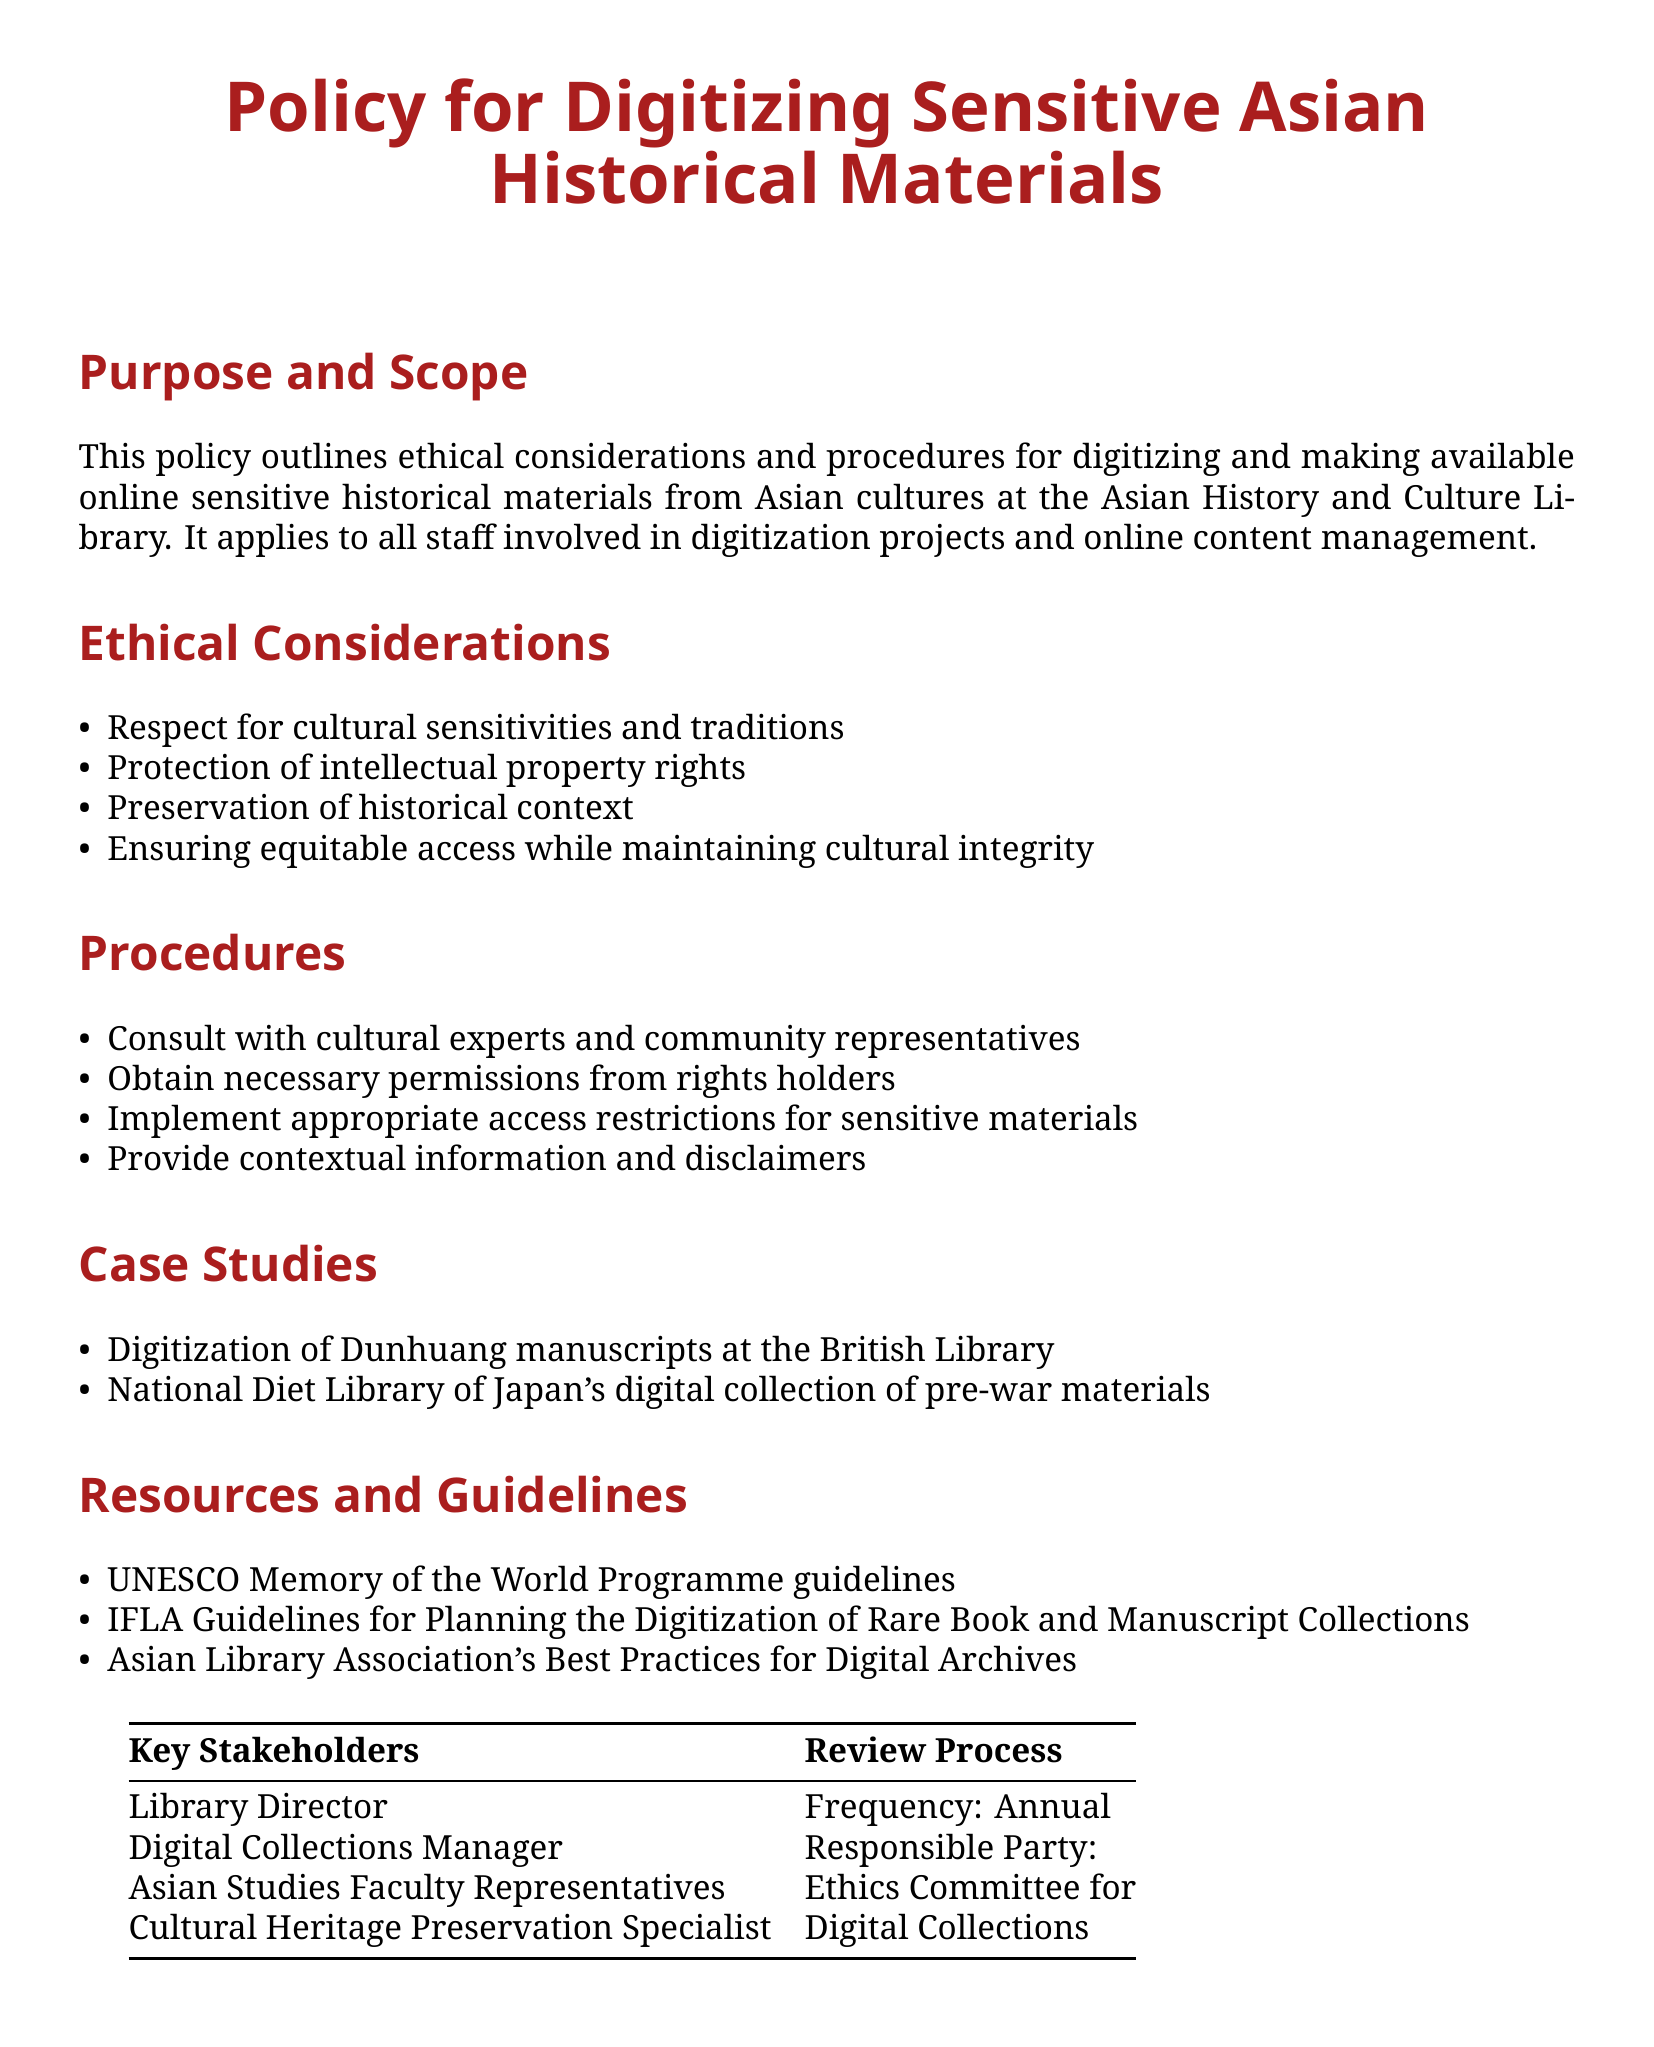What is the title of the policy document? The title is stated at the beginning of the document in bold, which is "Policy for Digitizing Sensitive Asian Historical Materials."
Answer: Policy for Digitizing Sensitive Asian Historical Materials Who is responsible for consulting cultural experts? This can be found in the Procedures section, which mentions that consulting with cultural experts is part of the process; the phrase "consult with cultural experts" indicates this.
Answer: Staff involved in digitization projects What is the purpose of this policy? The purpose is outlined at the beginning of the document, stating it is to outline ethical considerations and procedures for digitizing sensitive historical materials.
Answer: Ethical considerations and procedures for digitizing sensitive historical materials What is one of the ethical considerations mentioned? The list of ethical considerations includes respect for cultural sensitivities, which can be identified as one of the items.
Answer: Respect for cultural sensitivities How often is the review process scheduled? The document explicitly states that the frequency for the review process is annual, which can be found in the table under the Review Process.
Answer: Annual Who are the key stakeholders mentioned? The key stakeholders are listed in the table titled "Key Stakeholders," which includes the Library Director, Digital Collections Manager, among others.
Answer: Library Director, Digital Collections Manager, Asian Studies Faculty Representatives, Cultural Heritage Preservation Specialist What type of materials are being digitized according to the case studies? The case studies refer to specific types of materials; one case mentions "Dunhuang manuscripts," which are identified in the examples provided.
Answer: Dunhuang manuscripts What organization provides guidelines for digitization according to the Resources section? The Resources section mentions specific organizations; one of them is UNESCO, which is listed as part of the guidelines.
Answer: UNESCO What are the procedures for digitizing materials? The Procedures section outlines steps that begin with consulting experts and obtaining permissions, indicating a specific process that is both sequential and mandatory.
Answer: Consult with experts, obtain permissions, implement restrictions, provide disclaimers 